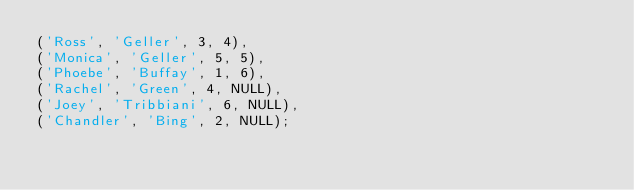Convert code to text. <code><loc_0><loc_0><loc_500><loc_500><_SQL_>('Ross', 'Geller', 3, 4),
('Monica', 'Geller', 5, 5),
('Phoebe', 'Buffay', 1, 6),
('Rachel', 'Green', 4, NULL),
('Joey', 'Tribbiani', 6, NULL),
('Chandler', 'Bing', 2, NULL);</code> 